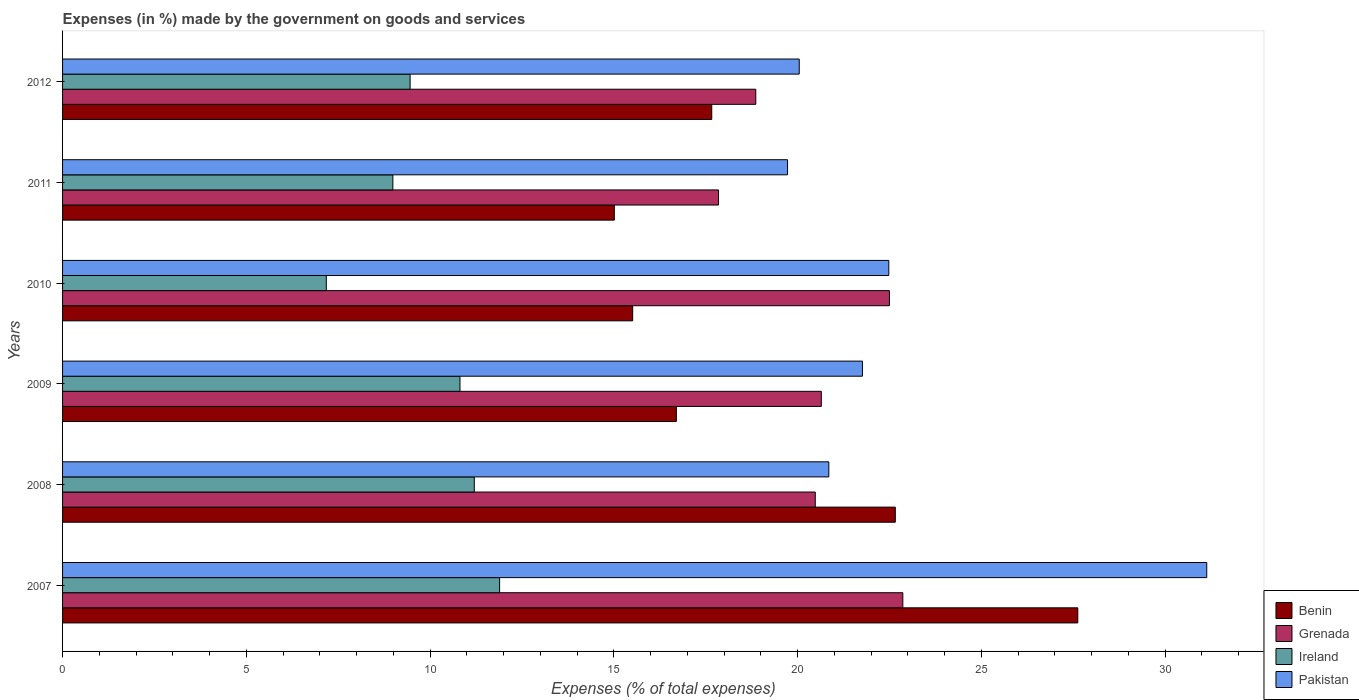How many different coloured bars are there?
Provide a short and direct response. 4. Are the number of bars per tick equal to the number of legend labels?
Ensure brevity in your answer.  Yes. How many bars are there on the 6th tick from the top?
Offer a terse response. 4. How many bars are there on the 4th tick from the bottom?
Give a very brief answer. 4. What is the label of the 2nd group of bars from the top?
Offer a very short reply. 2011. In how many cases, is the number of bars for a given year not equal to the number of legend labels?
Keep it short and to the point. 0. What is the percentage of expenses made by the government on goods and services in Pakistan in 2009?
Offer a very short reply. 21.76. Across all years, what is the maximum percentage of expenses made by the government on goods and services in Benin?
Provide a succinct answer. 27.62. Across all years, what is the minimum percentage of expenses made by the government on goods and services in Benin?
Offer a very short reply. 15.01. In which year was the percentage of expenses made by the government on goods and services in Benin minimum?
Ensure brevity in your answer.  2011. What is the total percentage of expenses made by the government on goods and services in Benin in the graph?
Your answer should be compact. 115.16. What is the difference between the percentage of expenses made by the government on goods and services in Pakistan in 2008 and that in 2009?
Your answer should be very brief. -0.92. What is the difference between the percentage of expenses made by the government on goods and services in Benin in 2009 and the percentage of expenses made by the government on goods and services in Grenada in 2012?
Your answer should be compact. -2.16. What is the average percentage of expenses made by the government on goods and services in Pakistan per year?
Give a very brief answer. 22.66. In the year 2007, what is the difference between the percentage of expenses made by the government on goods and services in Ireland and percentage of expenses made by the government on goods and services in Grenada?
Offer a very short reply. -10.97. What is the ratio of the percentage of expenses made by the government on goods and services in Ireland in 2009 to that in 2012?
Offer a very short reply. 1.14. Is the percentage of expenses made by the government on goods and services in Grenada in 2011 less than that in 2012?
Offer a terse response. Yes. Is the difference between the percentage of expenses made by the government on goods and services in Ireland in 2011 and 2012 greater than the difference between the percentage of expenses made by the government on goods and services in Grenada in 2011 and 2012?
Provide a short and direct response. Yes. What is the difference between the highest and the second highest percentage of expenses made by the government on goods and services in Grenada?
Provide a short and direct response. 0.36. What is the difference between the highest and the lowest percentage of expenses made by the government on goods and services in Pakistan?
Your response must be concise. 11.41. What does the 3rd bar from the top in 2012 represents?
Make the answer very short. Grenada. How many bars are there?
Give a very brief answer. 24. Are all the bars in the graph horizontal?
Provide a succinct answer. Yes. How many years are there in the graph?
Ensure brevity in your answer.  6. Are the values on the major ticks of X-axis written in scientific E-notation?
Your answer should be compact. No. Does the graph contain grids?
Your response must be concise. No. Where does the legend appear in the graph?
Keep it short and to the point. Bottom right. How many legend labels are there?
Your answer should be compact. 4. How are the legend labels stacked?
Keep it short and to the point. Vertical. What is the title of the graph?
Offer a very short reply. Expenses (in %) made by the government on goods and services. Does "Sri Lanka" appear as one of the legend labels in the graph?
Your response must be concise. No. What is the label or title of the X-axis?
Provide a succinct answer. Expenses (% of total expenses). What is the label or title of the Y-axis?
Offer a terse response. Years. What is the Expenses (% of total expenses) of Benin in 2007?
Make the answer very short. 27.62. What is the Expenses (% of total expenses) in Grenada in 2007?
Offer a terse response. 22.86. What is the Expenses (% of total expenses) in Ireland in 2007?
Your response must be concise. 11.89. What is the Expenses (% of total expenses) in Pakistan in 2007?
Provide a short and direct response. 31.13. What is the Expenses (% of total expenses) in Benin in 2008?
Your answer should be very brief. 22.66. What is the Expenses (% of total expenses) in Grenada in 2008?
Ensure brevity in your answer.  20.48. What is the Expenses (% of total expenses) of Ireland in 2008?
Your response must be concise. 11.2. What is the Expenses (% of total expenses) of Pakistan in 2008?
Your response must be concise. 20.85. What is the Expenses (% of total expenses) of Benin in 2009?
Offer a very short reply. 16.7. What is the Expenses (% of total expenses) in Grenada in 2009?
Provide a succinct answer. 20.64. What is the Expenses (% of total expenses) of Ireland in 2009?
Provide a short and direct response. 10.81. What is the Expenses (% of total expenses) in Pakistan in 2009?
Your answer should be compact. 21.76. What is the Expenses (% of total expenses) in Benin in 2010?
Your answer should be very brief. 15.51. What is the Expenses (% of total expenses) of Grenada in 2010?
Provide a short and direct response. 22.5. What is the Expenses (% of total expenses) of Ireland in 2010?
Your response must be concise. 7.18. What is the Expenses (% of total expenses) in Pakistan in 2010?
Your response must be concise. 22.48. What is the Expenses (% of total expenses) in Benin in 2011?
Make the answer very short. 15.01. What is the Expenses (% of total expenses) in Grenada in 2011?
Ensure brevity in your answer.  17.85. What is the Expenses (% of total expenses) in Ireland in 2011?
Give a very brief answer. 8.99. What is the Expenses (% of total expenses) of Pakistan in 2011?
Give a very brief answer. 19.72. What is the Expenses (% of total expenses) of Benin in 2012?
Give a very brief answer. 17.66. What is the Expenses (% of total expenses) in Grenada in 2012?
Your response must be concise. 18.86. What is the Expenses (% of total expenses) of Ireland in 2012?
Provide a short and direct response. 9.46. What is the Expenses (% of total expenses) in Pakistan in 2012?
Ensure brevity in your answer.  20.04. Across all years, what is the maximum Expenses (% of total expenses) in Benin?
Provide a succinct answer. 27.62. Across all years, what is the maximum Expenses (% of total expenses) of Grenada?
Provide a short and direct response. 22.86. Across all years, what is the maximum Expenses (% of total expenses) of Ireland?
Give a very brief answer. 11.89. Across all years, what is the maximum Expenses (% of total expenses) of Pakistan?
Provide a succinct answer. 31.13. Across all years, what is the minimum Expenses (% of total expenses) of Benin?
Your answer should be very brief. 15.01. Across all years, what is the minimum Expenses (% of total expenses) in Grenada?
Your answer should be very brief. 17.85. Across all years, what is the minimum Expenses (% of total expenses) of Ireland?
Your answer should be compact. 7.18. Across all years, what is the minimum Expenses (% of total expenses) in Pakistan?
Provide a short and direct response. 19.72. What is the total Expenses (% of total expenses) in Benin in the graph?
Provide a succinct answer. 115.16. What is the total Expenses (% of total expenses) of Grenada in the graph?
Provide a short and direct response. 123.19. What is the total Expenses (% of total expenses) in Ireland in the graph?
Provide a succinct answer. 59.52. What is the total Expenses (% of total expenses) of Pakistan in the graph?
Provide a succinct answer. 135.99. What is the difference between the Expenses (% of total expenses) in Benin in 2007 and that in 2008?
Your answer should be compact. 4.97. What is the difference between the Expenses (% of total expenses) of Grenada in 2007 and that in 2008?
Offer a very short reply. 2.38. What is the difference between the Expenses (% of total expenses) of Ireland in 2007 and that in 2008?
Your answer should be very brief. 0.69. What is the difference between the Expenses (% of total expenses) in Pakistan in 2007 and that in 2008?
Provide a short and direct response. 10.28. What is the difference between the Expenses (% of total expenses) of Benin in 2007 and that in 2009?
Offer a very short reply. 10.92. What is the difference between the Expenses (% of total expenses) of Grenada in 2007 and that in 2009?
Provide a short and direct response. 2.22. What is the difference between the Expenses (% of total expenses) of Ireland in 2007 and that in 2009?
Your answer should be compact. 1.08. What is the difference between the Expenses (% of total expenses) of Pakistan in 2007 and that in 2009?
Your answer should be very brief. 9.37. What is the difference between the Expenses (% of total expenses) in Benin in 2007 and that in 2010?
Make the answer very short. 12.11. What is the difference between the Expenses (% of total expenses) in Grenada in 2007 and that in 2010?
Offer a terse response. 0.36. What is the difference between the Expenses (% of total expenses) in Ireland in 2007 and that in 2010?
Your response must be concise. 4.71. What is the difference between the Expenses (% of total expenses) of Pakistan in 2007 and that in 2010?
Your answer should be compact. 8.65. What is the difference between the Expenses (% of total expenses) of Benin in 2007 and that in 2011?
Offer a terse response. 12.61. What is the difference between the Expenses (% of total expenses) in Grenada in 2007 and that in 2011?
Provide a short and direct response. 5.01. What is the difference between the Expenses (% of total expenses) in Ireland in 2007 and that in 2011?
Give a very brief answer. 2.9. What is the difference between the Expenses (% of total expenses) in Pakistan in 2007 and that in 2011?
Offer a very short reply. 11.41. What is the difference between the Expenses (% of total expenses) in Benin in 2007 and that in 2012?
Your answer should be very brief. 9.96. What is the difference between the Expenses (% of total expenses) of Grenada in 2007 and that in 2012?
Make the answer very short. 4. What is the difference between the Expenses (% of total expenses) of Ireland in 2007 and that in 2012?
Offer a terse response. 2.43. What is the difference between the Expenses (% of total expenses) of Pakistan in 2007 and that in 2012?
Make the answer very short. 11.09. What is the difference between the Expenses (% of total expenses) of Benin in 2008 and that in 2009?
Your answer should be very brief. 5.96. What is the difference between the Expenses (% of total expenses) of Grenada in 2008 and that in 2009?
Your answer should be very brief. -0.16. What is the difference between the Expenses (% of total expenses) in Ireland in 2008 and that in 2009?
Offer a very short reply. 0.39. What is the difference between the Expenses (% of total expenses) of Pakistan in 2008 and that in 2009?
Keep it short and to the point. -0.92. What is the difference between the Expenses (% of total expenses) of Benin in 2008 and that in 2010?
Your answer should be very brief. 7.15. What is the difference between the Expenses (% of total expenses) in Grenada in 2008 and that in 2010?
Give a very brief answer. -2.02. What is the difference between the Expenses (% of total expenses) of Ireland in 2008 and that in 2010?
Offer a very short reply. 4.03. What is the difference between the Expenses (% of total expenses) in Pakistan in 2008 and that in 2010?
Give a very brief answer. -1.63. What is the difference between the Expenses (% of total expenses) in Benin in 2008 and that in 2011?
Offer a terse response. 7.64. What is the difference between the Expenses (% of total expenses) in Grenada in 2008 and that in 2011?
Your answer should be very brief. 2.63. What is the difference between the Expenses (% of total expenses) of Ireland in 2008 and that in 2011?
Provide a succinct answer. 2.22. What is the difference between the Expenses (% of total expenses) of Pakistan in 2008 and that in 2011?
Offer a very short reply. 1.12. What is the difference between the Expenses (% of total expenses) in Benin in 2008 and that in 2012?
Offer a terse response. 4.99. What is the difference between the Expenses (% of total expenses) of Grenada in 2008 and that in 2012?
Ensure brevity in your answer.  1.62. What is the difference between the Expenses (% of total expenses) in Ireland in 2008 and that in 2012?
Ensure brevity in your answer.  1.75. What is the difference between the Expenses (% of total expenses) of Pakistan in 2008 and that in 2012?
Provide a succinct answer. 0.8. What is the difference between the Expenses (% of total expenses) of Benin in 2009 and that in 2010?
Keep it short and to the point. 1.19. What is the difference between the Expenses (% of total expenses) in Grenada in 2009 and that in 2010?
Offer a very short reply. -1.85. What is the difference between the Expenses (% of total expenses) in Ireland in 2009 and that in 2010?
Ensure brevity in your answer.  3.64. What is the difference between the Expenses (% of total expenses) of Pakistan in 2009 and that in 2010?
Provide a short and direct response. -0.72. What is the difference between the Expenses (% of total expenses) in Benin in 2009 and that in 2011?
Offer a very short reply. 1.69. What is the difference between the Expenses (% of total expenses) in Grenada in 2009 and that in 2011?
Ensure brevity in your answer.  2.8. What is the difference between the Expenses (% of total expenses) of Ireland in 2009 and that in 2011?
Offer a terse response. 1.83. What is the difference between the Expenses (% of total expenses) of Pakistan in 2009 and that in 2011?
Ensure brevity in your answer.  2.04. What is the difference between the Expenses (% of total expenses) of Benin in 2009 and that in 2012?
Offer a very short reply. -0.96. What is the difference between the Expenses (% of total expenses) in Grenada in 2009 and that in 2012?
Make the answer very short. 1.78. What is the difference between the Expenses (% of total expenses) in Ireland in 2009 and that in 2012?
Provide a succinct answer. 1.36. What is the difference between the Expenses (% of total expenses) in Pakistan in 2009 and that in 2012?
Offer a very short reply. 1.72. What is the difference between the Expenses (% of total expenses) in Benin in 2010 and that in 2011?
Give a very brief answer. 0.5. What is the difference between the Expenses (% of total expenses) of Grenada in 2010 and that in 2011?
Your response must be concise. 4.65. What is the difference between the Expenses (% of total expenses) of Ireland in 2010 and that in 2011?
Make the answer very short. -1.81. What is the difference between the Expenses (% of total expenses) of Pakistan in 2010 and that in 2011?
Your answer should be very brief. 2.75. What is the difference between the Expenses (% of total expenses) of Benin in 2010 and that in 2012?
Offer a very short reply. -2.15. What is the difference between the Expenses (% of total expenses) of Grenada in 2010 and that in 2012?
Give a very brief answer. 3.64. What is the difference between the Expenses (% of total expenses) in Ireland in 2010 and that in 2012?
Your answer should be compact. -2.28. What is the difference between the Expenses (% of total expenses) in Pakistan in 2010 and that in 2012?
Your response must be concise. 2.44. What is the difference between the Expenses (% of total expenses) in Benin in 2011 and that in 2012?
Your answer should be compact. -2.65. What is the difference between the Expenses (% of total expenses) in Grenada in 2011 and that in 2012?
Ensure brevity in your answer.  -1.01. What is the difference between the Expenses (% of total expenses) in Ireland in 2011 and that in 2012?
Provide a succinct answer. -0.47. What is the difference between the Expenses (% of total expenses) in Pakistan in 2011 and that in 2012?
Provide a succinct answer. -0.32. What is the difference between the Expenses (% of total expenses) of Benin in 2007 and the Expenses (% of total expenses) of Grenada in 2008?
Offer a terse response. 7.14. What is the difference between the Expenses (% of total expenses) in Benin in 2007 and the Expenses (% of total expenses) in Ireland in 2008?
Make the answer very short. 16.42. What is the difference between the Expenses (% of total expenses) in Benin in 2007 and the Expenses (% of total expenses) in Pakistan in 2008?
Give a very brief answer. 6.77. What is the difference between the Expenses (% of total expenses) in Grenada in 2007 and the Expenses (% of total expenses) in Ireland in 2008?
Ensure brevity in your answer.  11.66. What is the difference between the Expenses (% of total expenses) in Grenada in 2007 and the Expenses (% of total expenses) in Pakistan in 2008?
Your response must be concise. 2.01. What is the difference between the Expenses (% of total expenses) of Ireland in 2007 and the Expenses (% of total expenses) of Pakistan in 2008?
Offer a very short reply. -8.96. What is the difference between the Expenses (% of total expenses) in Benin in 2007 and the Expenses (% of total expenses) in Grenada in 2009?
Offer a very short reply. 6.98. What is the difference between the Expenses (% of total expenses) in Benin in 2007 and the Expenses (% of total expenses) in Ireland in 2009?
Ensure brevity in your answer.  16.81. What is the difference between the Expenses (% of total expenses) of Benin in 2007 and the Expenses (% of total expenses) of Pakistan in 2009?
Ensure brevity in your answer.  5.86. What is the difference between the Expenses (% of total expenses) in Grenada in 2007 and the Expenses (% of total expenses) in Ireland in 2009?
Offer a very short reply. 12.05. What is the difference between the Expenses (% of total expenses) of Grenada in 2007 and the Expenses (% of total expenses) of Pakistan in 2009?
Make the answer very short. 1.1. What is the difference between the Expenses (% of total expenses) of Ireland in 2007 and the Expenses (% of total expenses) of Pakistan in 2009?
Keep it short and to the point. -9.87. What is the difference between the Expenses (% of total expenses) of Benin in 2007 and the Expenses (% of total expenses) of Grenada in 2010?
Provide a succinct answer. 5.12. What is the difference between the Expenses (% of total expenses) of Benin in 2007 and the Expenses (% of total expenses) of Ireland in 2010?
Provide a succinct answer. 20.45. What is the difference between the Expenses (% of total expenses) of Benin in 2007 and the Expenses (% of total expenses) of Pakistan in 2010?
Ensure brevity in your answer.  5.14. What is the difference between the Expenses (% of total expenses) in Grenada in 2007 and the Expenses (% of total expenses) in Ireland in 2010?
Your answer should be very brief. 15.69. What is the difference between the Expenses (% of total expenses) of Grenada in 2007 and the Expenses (% of total expenses) of Pakistan in 2010?
Your response must be concise. 0.38. What is the difference between the Expenses (% of total expenses) in Ireland in 2007 and the Expenses (% of total expenses) in Pakistan in 2010?
Give a very brief answer. -10.59. What is the difference between the Expenses (% of total expenses) in Benin in 2007 and the Expenses (% of total expenses) in Grenada in 2011?
Provide a succinct answer. 9.77. What is the difference between the Expenses (% of total expenses) in Benin in 2007 and the Expenses (% of total expenses) in Ireland in 2011?
Offer a very short reply. 18.64. What is the difference between the Expenses (% of total expenses) of Benin in 2007 and the Expenses (% of total expenses) of Pakistan in 2011?
Provide a succinct answer. 7.9. What is the difference between the Expenses (% of total expenses) in Grenada in 2007 and the Expenses (% of total expenses) in Ireland in 2011?
Provide a succinct answer. 13.87. What is the difference between the Expenses (% of total expenses) in Grenada in 2007 and the Expenses (% of total expenses) in Pakistan in 2011?
Give a very brief answer. 3.14. What is the difference between the Expenses (% of total expenses) of Ireland in 2007 and the Expenses (% of total expenses) of Pakistan in 2011?
Provide a succinct answer. -7.83. What is the difference between the Expenses (% of total expenses) in Benin in 2007 and the Expenses (% of total expenses) in Grenada in 2012?
Your answer should be compact. 8.76. What is the difference between the Expenses (% of total expenses) in Benin in 2007 and the Expenses (% of total expenses) in Ireland in 2012?
Your response must be concise. 18.17. What is the difference between the Expenses (% of total expenses) in Benin in 2007 and the Expenses (% of total expenses) in Pakistan in 2012?
Provide a succinct answer. 7.58. What is the difference between the Expenses (% of total expenses) of Grenada in 2007 and the Expenses (% of total expenses) of Ireland in 2012?
Make the answer very short. 13.41. What is the difference between the Expenses (% of total expenses) in Grenada in 2007 and the Expenses (% of total expenses) in Pakistan in 2012?
Your response must be concise. 2.82. What is the difference between the Expenses (% of total expenses) of Ireland in 2007 and the Expenses (% of total expenses) of Pakistan in 2012?
Give a very brief answer. -8.15. What is the difference between the Expenses (% of total expenses) in Benin in 2008 and the Expenses (% of total expenses) in Grenada in 2009?
Offer a very short reply. 2.01. What is the difference between the Expenses (% of total expenses) of Benin in 2008 and the Expenses (% of total expenses) of Ireland in 2009?
Your answer should be very brief. 11.84. What is the difference between the Expenses (% of total expenses) of Benin in 2008 and the Expenses (% of total expenses) of Pakistan in 2009?
Offer a very short reply. 0.89. What is the difference between the Expenses (% of total expenses) of Grenada in 2008 and the Expenses (% of total expenses) of Ireland in 2009?
Offer a very short reply. 9.67. What is the difference between the Expenses (% of total expenses) in Grenada in 2008 and the Expenses (% of total expenses) in Pakistan in 2009?
Make the answer very short. -1.28. What is the difference between the Expenses (% of total expenses) of Ireland in 2008 and the Expenses (% of total expenses) of Pakistan in 2009?
Your answer should be very brief. -10.56. What is the difference between the Expenses (% of total expenses) of Benin in 2008 and the Expenses (% of total expenses) of Grenada in 2010?
Your response must be concise. 0.16. What is the difference between the Expenses (% of total expenses) of Benin in 2008 and the Expenses (% of total expenses) of Ireland in 2010?
Make the answer very short. 15.48. What is the difference between the Expenses (% of total expenses) in Benin in 2008 and the Expenses (% of total expenses) in Pakistan in 2010?
Provide a short and direct response. 0.18. What is the difference between the Expenses (% of total expenses) of Grenada in 2008 and the Expenses (% of total expenses) of Ireland in 2010?
Your response must be concise. 13.3. What is the difference between the Expenses (% of total expenses) in Grenada in 2008 and the Expenses (% of total expenses) in Pakistan in 2010?
Ensure brevity in your answer.  -2. What is the difference between the Expenses (% of total expenses) in Ireland in 2008 and the Expenses (% of total expenses) in Pakistan in 2010?
Offer a very short reply. -11.28. What is the difference between the Expenses (% of total expenses) of Benin in 2008 and the Expenses (% of total expenses) of Grenada in 2011?
Your response must be concise. 4.81. What is the difference between the Expenses (% of total expenses) in Benin in 2008 and the Expenses (% of total expenses) in Ireland in 2011?
Give a very brief answer. 13.67. What is the difference between the Expenses (% of total expenses) of Benin in 2008 and the Expenses (% of total expenses) of Pakistan in 2011?
Offer a very short reply. 2.93. What is the difference between the Expenses (% of total expenses) of Grenada in 2008 and the Expenses (% of total expenses) of Ireland in 2011?
Offer a very short reply. 11.49. What is the difference between the Expenses (% of total expenses) of Grenada in 2008 and the Expenses (% of total expenses) of Pakistan in 2011?
Your answer should be compact. 0.75. What is the difference between the Expenses (% of total expenses) in Ireland in 2008 and the Expenses (% of total expenses) in Pakistan in 2011?
Offer a terse response. -8.52. What is the difference between the Expenses (% of total expenses) of Benin in 2008 and the Expenses (% of total expenses) of Grenada in 2012?
Your answer should be very brief. 3.8. What is the difference between the Expenses (% of total expenses) in Benin in 2008 and the Expenses (% of total expenses) in Ireland in 2012?
Keep it short and to the point. 13.2. What is the difference between the Expenses (% of total expenses) of Benin in 2008 and the Expenses (% of total expenses) of Pakistan in 2012?
Offer a very short reply. 2.61. What is the difference between the Expenses (% of total expenses) in Grenada in 2008 and the Expenses (% of total expenses) in Ireland in 2012?
Offer a very short reply. 11.02. What is the difference between the Expenses (% of total expenses) in Grenada in 2008 and the Expenses (% of total expenses) in Pakistan in 2012?
Ensure brevity in your answer.  0.44. What is the difference between the Expenses (% of total expenses) of Ireland in 2008 and the Expenses (% of total expenses) of Pakistan in 2012?
Your answer should be compact. -8.84. What is the difference between the Expenses (% of total expenses) of Benin in 2009 and the Expenses (% of total expenses) of Grenada in 2010?
Your answer should be very brief. -5.8. What is the difference between the Expenses (% of total expenses) in Benin in 2009 and the Expenses (% of total expenses) in Ireland in 2010?
Keep it short and to the point. 9.52. What is the difference between the Expenses (% of total expenses) in Benin in 2009 and the Expenses (% of total expenses) in Pakistan in 2010?
Keep it short and to the point. -5.78. What is the difference between the Expenses (% of total expenses) in Grenada in 2009 and the Expenses (% of total expenses) in Ireland in 2010?
Provide a short and direct response. 13.47. What is the difference between the Expenses (% of total expenses) of Grenada in 2009 and the Expenses (% of total expenses) of Pakistan in 2010?
Provide a succinct answer. -1.84. What is the difference between the Expenses (% of total expenses) of Ireland in 2009 and the Expenses (% of total expenses) of Pakistan in 2010?
Offer a terse response. -11.67. What is the difference between the Expenses (% of total expenses) in Benin in 2009 and the Expenses (% of total expenses) in Grenada in 2011?
Ensure brevity in your answer.  -1.15. What is the difference between the Expenses (% of total expenses) of Benin in 2009 and the Expenses (% of total expenses) of Ireland in 2011?
Give a very brief answer. 7.71. What is the difference between the Expenses (% of total expenses) of Benin in 2009 and the Expenses (% of total expenses) of Pakistan in 2011?
Provide a succinct answer. -3.03. What is the difference between the Expenses (% of total expenses) in Grenada in 2009 and the Expenses (% of total expenses) in Ireland in 2011?
Make the answer very short. 11.66. What is the difference between the Expenses (% of total expenses) of Grenada in 2009 and the Expenses (% of total expenses) of Pakistan in 2011?
Your answer should be compact. 0.92. What is the difference between the Expenses (% of total expenses) in Ireland in 2009 and the Expenses (% of total expenses) in Pakistan in 2011?
Your answer should be very brief. -8.91. What is the difference between the Expenses (% of total expenses) of Benin in 2009 and the Expenses (% of total expenses) of Grenada in 2012?
Provide a succinct answer. -2.16. What is the difference between the Expenses (% of total expenses) in Benin in 2009 and the Expenses (% of total expenses) in Ireland in 2012?
Your response must be concise. 7.24. What is the difference between the Expenses (% of total expenses) in Benin in 2009 and the Expenses (% of total expenses) in Pakistan in 2012?
Give a very brief answer. -3.34. What is the difference between the Expenses (% of total expenses) of Grenada in 2009 and the Expenses (% of total expenses) of Ireland in 2012?
Give a very brief answer. 11.19. What is the difference between the Expenses (% of total expenses) of Grenada in 2009 and the Expenses (% of total expenses) of Pakistan in 2012?
Ensure brevity in your answer.  0.6. What is the difference between the Expenses (% of total expenses) in Ireland in 2009 and the Expenses (% of total expenses) in Pakistan in 2012?
Your response must be concise. -9.23. What is the difference between the Expenses (% of total expenses) in Benin in 2010 and the Expenses (% of total expenses) in Grenada in 2011?
Make the answer very short. -2.34. What is the difference between the Expenses (% of total expenses) of Benin in 2010 and the Expenses (% of total expenses) of Ireland in 2011?
Offer a terse response. 6.52. What is the difference between the Expenses (% of total expenses) of Benin in 2010 and the Expenses (% of total expenses) of Pakistan in 2011?
Make the answer very short. -4.21. What is the difference between the Expenses (% of total expenses) in Grenada in 2010 and the Expenses (% of total expenses) in Ireland in 2011?
Offer a terse response. 13.51. What is the difference between the Expenses (% of total expenses) of Grenada in 2010 and the Expenses (% of total expenses) of Pakistan in 2011?
Offer a very short reply. 2.77. What is the difference between the Expenses (% of total expenses) of Ireland in 2010 and the Expenses (% of total expenses) of Pakistan in 2011?
Offer a very short reply. -12.55. What is the difference between the Expenses (% of total expenses) of Benin in 2010 and the Expenses (% of total expenses) of Grenada in 2012?
Offer a terse response. -3.35. What is the difference between the Expenses (% of total expenses) of Benin in 2010 and the Expenses (% of total expenses) of Ireland in 2012?
Give a very brief answer. 6.06. What is the difference between the Expenses (% of total expenses) in Benin in 2010 and the Expenses (% of total expenses) in Pakistan in 2012?
Your response must be concise. -4.53. What is the difference between the Expenses (% of total expenses) of Grenada in 2010 and the Expenses (% of total expenses) of Ireland in 2012?
Provide a succinct answer. 13.04. What is the difference between the Expenses (% of total expenses) of Grenada in 2010 and the Expenses (% of total expenses) of Pakistan in 2012?
Provide a succinct answer. 2.45. What is the difference between the Expenses (% of total expenses) in Ireland in 2010 and the Expenses (% of total expenses) in Pakistan in 2012?
Ensure brevity in your answer.  -12.87. What is the difference between the Expenses (% of total expenses) of Benin in 2011 and the Expenses (% of total expenses) of Grenada in 2012?
Ensure brevity in your answer.  -3.85. What is the difference between the Expenses (% of total expenses) in Benin in 2011 and the Expenses (% of total expenses) in Ireland in 2012?
Your answer should be very brief. 5.56. What is the difference between the Expenses (% of total expenses) in Benin in 2011 and the Expenses (% of total expenses) in Pakistan in 2012?
Your answer should be compact. -5.03. What is the difference between the Expenses (% of total expenses) of Grenada in 2011 and the Expenses (% of total expenses) of Ireland in 2012?
Keep it short and to the point. 8.39. What is the difference between the Expenses (% of total expenses) of Grenada in 2011 and the Expenses (% of total expenses) of Pakistan in 2012?
Make the answer very short. -2.2. What is the difference between the Expenses (% of total expenses) of Ireland in 2011 and the Expenses (% of total expenses) of Pakistan in 2012?
Make the answer very short. -11.06. What is the average Expenses (% of total expenses) in Benin per year?
Make the answer very short. 19.19. What is the average Expenses (% of total expenses) in Grenada per year?
Make the answer very short. 20.53. What is the average Expenses (% of total expenses) in Ireland per year?
Provide a short and direct response. 9.92. What is the average Expenses (% of total expenses) of Pakistan per year?
Your answer should be very brief. 22.66. In the year 2007, what is the difference between the Expenses (% of total expenses) of Benin and Expenses (% of total expenses) of Grenada?
Make the answer very short. 4.76. In the year 2007, what is the difference between the Expenses (% of total expenses) of Benin and Expenses (% of total expenses) of Ireland?
Provide a succinct answer. 15.73. In the year 2007, what is the difference between the Expenses (% of total expenses) in Benin and Expenses (% of total expenses) in Pakistan?
Offer a terse response. -3.51. In the year 2007, what is the difference between the Expenses (% of total expenses) in Grenada and Expenses (% of total expenses) in Ireland?
Make the answer very short. 10.97. In the year 2007, what is the difference between the Expenses (% of total expenses) in Grenada and Expenses (% of total expenses) in Pakistan?
Ensure brevity in your answer.  -8.27. In the year 2007, what is the difference between the Expenses (% of total expenses) in Ireland and Expenses (% of total expenses) in Pakistan?
Make the answer very short. -19.24. In the year 2008, what is the difference between the Expenses (% of total expenses) of Benin and Expenses (% of total expenses) of Grenada?
Provide a succinct answer. 2.18. In the year 2008, what is the difference between the Expenses (% of total expenses) of Benin and Expenses (% of total expenses) of Ireland?
Provide a succinct answer. 11.45. In the year 2008, what is the difference between the Expenses (% of total expenses) of Benin and Expenses (% of total expenses) of Pakistan?
Your answer should be very brief. 1.81. In the year 2008, what is the difference between the Expenses (% of total expenses) in Grenada and Expenses (% of total expenses) in Ireland?
Your response must be concise. 9.28. In the year 2008, what is the difference between the Expenses (% of total expenses) of Grenada and Expenses (% of total expenses) of Pakistan?
Your answer should be very brief. -0.37. In the year 2008, what is the difference between the Expenses (% of total expenses) of Ireland and Expenses (% of total expenses) of Pakistan?
Provide a short and direct response. -9.65. In the year 2009, what is the difference between the Expenses (% of total expenses) in Benin and Expenses (% of total expenses) in Grenada?
Your answer should be compact. -3.94. In the year 2009, what is the difference between the Expenses (% of total expenses) in Benin and Expenses (% of total expenses) in Ireland?
Keep it short and to the point. 5.89. In the year 2009, what is the difference between the Expenses (% of total expenses) of Benin and Expenses (% of total expenses) of Pakistan?
Keep it short and to the point. -5.06. In the year 2009, what is the difference between the Expenses (% of total expenses) in Grenada and Expenses (% of total expenses) in Ireland?
Your answer should be compact. 9.83. In the year 2009, what is the difference between the Expenses (% of total expenses) of Grenada and Expenses (% of total expenses) of Pakistan?
Keep it short and to the point. -1.12. In the year 2009, what is the difference between the Expenses (% of total expenses) in Ireland and Expenses (% of total expenses) in Pakistan?
Offer a very short reply. -10.95. In the year 2010, what is the difference between the Expenses (% of total expenses) in Benin and Expenses (% of total expenses) in Grenada?
Give a very brief answer. -6.99. In the year 2010, what is the difference between the Expenses (% of total expenses) of Benin and Expenses (% of total expenses) of Ireland?
Provide a succinct answer. 8.34. In the year 2010, what is the difference between the Expenses (% of total expenses) of Benin and Expenses (% of total expenses) of Pakistan?
Offer a very short reply. -6.97. In the year 2010, what is the difference between the Expenses (% of total expenses) of Grenada and Expenses (% of total expenses) of Ireland?
Make the answer very short. 15.32. In the year 2010, what is the difference between the Expenses (% of total expenses) in Grenada and Expenses (% of total expenses) in Pakistan?
Your response must be concise. 0.02. In the year 2010, what is the difference between the Expenses (% of total expenses) of Ireland and Expenses (% of total expenses) of Pakistan?
Ensure brevity in your answer.  -15.3. In the year 2011, what is the difference between the Expenses (% of total expenses) in Benin and Expenses (% of total expenses) in Grenada?
Your answer should be compact. -2.84. In the year 2011, what is the difference between the Expenses (% of total expenses) in Benin and Expenses (% of total expenses) in Ireland?
Ensure brevity in your answer.  6.03. In the year 2011, what is the difference between the Expenses (% of total expenses) of Benin and Expenses (% of total expenses) of Pakistan?
Your answer should be very brief. -4.71. In the year 2011, what is the difference between the Expenses (% of total expenses) in Grenada and Expenses (% of total expenses) in Ireland?
Ensure brevity in your answer.  8.86. In the year 2011, what is the difference between the Expenses (% of total expenses) in Grenada and Expenses (% of total expenses) in Pakistan?
Make the answer very short. -1.88. In the year 2011, what is the difference between the Expenses (% of total expenses) of Ireland and Expenses (% of total expenses) of Pakistan?
Your answer should be very brief. -10.74. In the year 2012, what is the difference between the Expenses (% of total expenses) in Benin and Expenses (% of total expenses) in Grenada?
Your response must be concise. -1.2. In the year 2012, what is the difference between the Expenses (% of total expenses) in Benin and Expenses (% of total expenses) in Ireland?
Your answer should be compact. 8.21. In the year 2012, what is the difference between the Expenses (% of total expenses) of Benin and Expenses (% of total expenses) of Pakistan?
Give a very brief answer. -2.38. In the year 2012, what is the difference between the Expenses (% of total expenses) of Grenada and Expenses (% of total expenses) of Ireland?
Make the answer very short. 9.4. In the year 2012, what is the difference between the Expenses (% of total expenses) of Grenada and Expenses (% of total expenses) of Pakistan?
Your answer should be very brief. -1.18. In the year 2012, what is the difference between the Expenses (% of total expenses) of Ireland and Expenses (% of total expenses) of Pakistan?
Your answer should be compact. -10.59. What is the ratio of the Expenses (% of total expenses) in Benin in 2007 to that in 2008?
Make the answer very short. 1.22. What is the ratio of the Expenses (% of total expenses) in Grenada in 2007 to that in 2008?
Provide a short and direct response. 1.12. What is the ratio of the Expenses (% of total expenses) of Ireland in 2007 to that in 2008?
Give a very brief answer. 1.06. What is the ratio of the Expenses (% of total expenses) of Pakistan in 2007 to that in 2008?
Your response must be concise. 1.49. What is the ratio of the Expenses (% of total expenses) in Benin in 2007 to that in 2009?
Ensure brevity in your answer.  1.65. What is the ratio of the Expenses (% of total expenses) in Grenada in 2007 to that in 2009?
Your answer should be compact. 1.11. What is the ratio of the Expenses (% of total expenses) in Ireland in 2007 to that in 2009?
Give a very brief answer. 1.1. What is the ratio of the Expenses (% of total expenses) in Pakistan in 2007 to that in 2009?
Keep it short and to the point. 1.43. What is the ratio of the Expenses (% of total expenses) in Benin in 2007 to that in 2010?
Keep it short and to the point. 1.78. What is the ratio of the Expenses (% of total expenses) of Grenada in 2007 to that in 2010?
Provide a succinct answer. 1.02. What is the ratio of the Expenses (% of total expenses) of Ireland in 2007 to that in 2010?
Offer a terse response. 1.66. What is the ratio of the Expenses (% of total expenses) in Pakistan in 2007 to that in 2010?
Provide a succinct answer. 1.38. What is the ratio of the Expenses (% of total expenses) of Benin in 2007 to that in 2011?
Keep it short and to the point. 1.84. What is the ratio of the Expenses (% of total expenses) in Grenada in 2007 to that in 2011?
Your response must be concise. 1.28. What is the ratio of the Expenses (% of total expenses) of Ireland in 2007 to that in 2011?
Offer a very short reply. 1.32. What is the ratio of the Expenses (% of total expenses) of Pakistan in 2007 to that in 2011?
Give a very brief answer. 1.58. What is the ratio of the Expenses (% of total expenses) in Benin in 2007 to that in 2012?
Keep it short and to the point. 1.56. What is the ratio of the Expenses (% of total expenses) in Grenada in 2007 to that in 2012?
Ensure brevity in your answer.  1.21. What is the ratio of the Expenses (% of total expenses) in Ireland in 2007 to that in 2012?
Ensure brevity in your answer.  1.26. What is the ratio of the Expenses (% of total expenses) in Pakistan in 2007 to that in 2012?
Provide a short and direct response. 1.55. What is the ratio of the Expenses (% of total expenses) of Benin in 2008 to that in 2009?
Your answer should be very brief. 1.36. What is the ratio of the Expenses (% of total expenses) of Ireland in 2008 to that in 2009?
Make the answer very short. 1.04. What is the ratio of the Expenses (% of total expenses) of Pakistan in 2008 to that in 2009?
Make the answer very short. 0.96. What is the ratio of the Expenses (% of total expenses) of Benin in 2008 to that in 2010?
Keep it short and to the point. 1.46. What is the ratio of the Expenses (% of total expenses) of Grenada in 2008 to that in 2010?
Make the answer very short. 0.91. What is the ratio of the Expenses (% of total expenses) of Ireland in 2008 to that in 2010?
Give a very brief answer. 1.56. What is the ratio of the Expenses (% of total expenses) of Pakistan in 2008 to that in 2010?
Make the answer very short. 0.93. What is the ratio of the Expenses (% of total expenses) of Benin in 2008 to that in 2011?
Provide a succinct answer. 1.51. What is the ratio of the Expenses (% of total expenses) in Grenada in 2008 to that in 2011?
Provide a short and direct response. 1.15. What is the ratio of the Expenses (% of total expenses) in Ireland in 2008 to that in 2011?
Ensure brevity in your answer.  1.25. What is the ratio of the Expenses (% of total expenses) of Pakistan in 2008 to that in 2011?
Offer a terse response. 1.06. What is the ratio of the Expenses (% of total expenses) of Benin in 2008 to that in 2012?
Your answer should be very brief. 1.28. What is the ratio of the Expenses (% of total expenses) in Grenada in 2008 to that in 2012?
Ensure brevity in your answer.  1.09. What is the ratio of the Expenses (% of total expenses) in Ireland in 2008 to that in 2012?
Your answer should be very brief. 1.18. What is the ratio of the Expenses (% of total expenses) in Pakistan in 2008 to that in 2012?
Provide a succinct answer. 1.04. What is the ratio of the Expenses (% of total expenses) of Benin in 2009 to that in 2010?
Your answer should be compact. 1.08. What is the ratio of the Expenses (% of total expenses) in Grenada in 2009 to that in 2010?
Ensure brevity in your answer.  0.92. What is the ratio of the Expenses (% of total expenses) of Ireland in 2009 to that in 2010?
Your answer should be very brief. 1.51. What is the ratio of the Expenses (% of total expenses) in Pakistan in 2009 to that in 2010?
Your response must be concise. 0.97. What is the ratio of the Expenses (% of total expenses) of Benin in 2009 to that in 2011?
Make the answer very short. 1.11. What is the ratio of the Expenses (% of total expenses) in Grenada in 2009 to that in 2011?
Offer a very short reply. 1.16. What is the ratio of the Expenses (% of total expenses) in Ireland in 2009 to that in 2011?
Your answer should be very brief. 1.2. What is the ratio of the Expenses (% of total expenses) in Pakistan in 2009 to that in 2011?
Offer a terse response. 1.1. What is the ratio of the Expenses (% of total expenses) of Benin in 2009 to that in 2012?
Keep it short and to the point. 0.95. What is the ratio of the Expenses (% of total expenses) of Grenada in 2009 to that in 2012?
Give a very brief answer. 1.09. What is the ratio of the Expenses (% of total expenses) in Ireland in 2009 to that in 2012?
Provide a short and direct response. 1.14. What is the ratio of the Expenses (% of total expenses) in Pakistan in 2009 to that in 2012?
Give a very brief answer. 1.09. What is the ratio of the Expenses (% of total expenses) in Grenada in 2010 to that in 2011?
Your response must be concise. 1.26. What is the ratio of the Expenses (% of total expenses) in Ireland in 2010 to that in 2011?
Your answer should be compact. 0.8. What is the ratio of the Expenses (% of total expenses) of Pakistan in 2010 to that in 2011?
Your answer should be very brief. 1.14. What is the ratio of the Expenses (% of total expenses) in Benin in 2010 to that in 2012?
Keep it short and to the point. 0.88. What is the ratio of the Expenses (% of total expenses) in Grenada in 2010 to that in 2012?
Offer a very short reply. 1.19. What is the ratio of the Expenses (% of total expenses) in Ireland in 2010 to that in 2012?
Ensure brevity in your answer.  0.76. What is the ratio of the Expenses (% of total expenses) of Pakistan in 2010 to that in 2012?
Offer a terse response. 1.12. What is the ratio of the Expenses (% of total expenses) in Benin in 2011 to that in 2012?
Your answer should be very brief. 0.85. What is the ratio of the Expenses (% of total expenses) of Grenada in 2011 to that in 2012?
Your answer should be compact. 0.95. What is the ratio of the Expenses (% of total expenses) of Ireland in 2011 to that in 2012?
Your response must be concise. 0.95. What is the ratio of the Expenses (% of total expenses) of Pakistan in 2011 to that in 2012?
Your response must be concise. 0.98. What is the difference between the highest and the second highest Expenses (% of total expenses) in Benin?
Provide a succinct answer. 4.97. What is the difference between the highest and the second highest Expenses (% of total expenses) of Grenada?
Provide a short and direct response. 0.36. What is the difference between the highest and the second highest Expenses (% of total expenses) of Ireland?
Give a very brief answer. 0.69. What is the difference between the highest and the second highest Expenses (% of total expenses) in Pakistan?
Offer a very short reply. 8.65. What is the difference between the highest and the lowest Expenses (% of total expenses) in Benin?
Ensure brevity in your answer.  12.61. What is the difference between the highest and the lowest Expenses (% of total expenses) of Grenada?
Your answer should be very brief. 5.01. What is the difference between the highest and the lowest Expenses (% of total expenses) in Ireland?
Ensure brevity in your answer.  4.71. What is the difference between the highest and the lowest Expenses (% of total expenses) in Pakistan?
Keep it short and to the point. 11.41. 